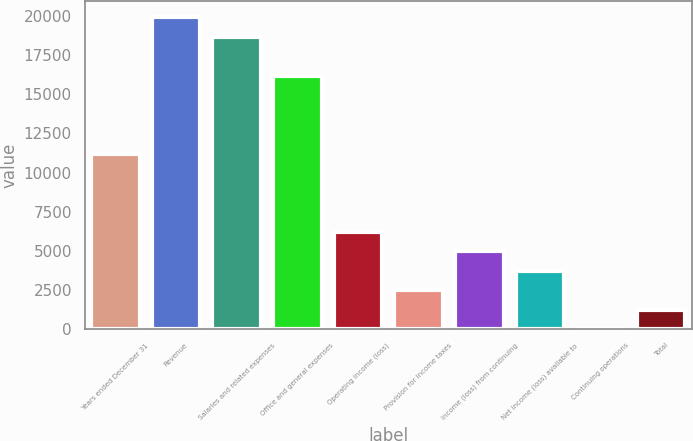<chart> <loc_0><loc_0><loc_500><loc_500><bar_chart><fcel>Years ended December 31<fcel>Revenue<fcel>Salaries and related expenses<fcel>Office and general expenses<fcel>Operating income (loss)<fcel>Provision for income taxes<fcel>Income (loss) from continuing<fcel>Net income (loss) available to<fcel>Continuing operations<fcel>Total<nl><fcel>11212.3<fcel>19932.8<fcel>18687<fcel>16195.4<fcel>6229.19<fcel>2491.85<fcel>4983.41<fcel>3737.63<fcel>0.29<fcel>1246.07<nl></chart> 